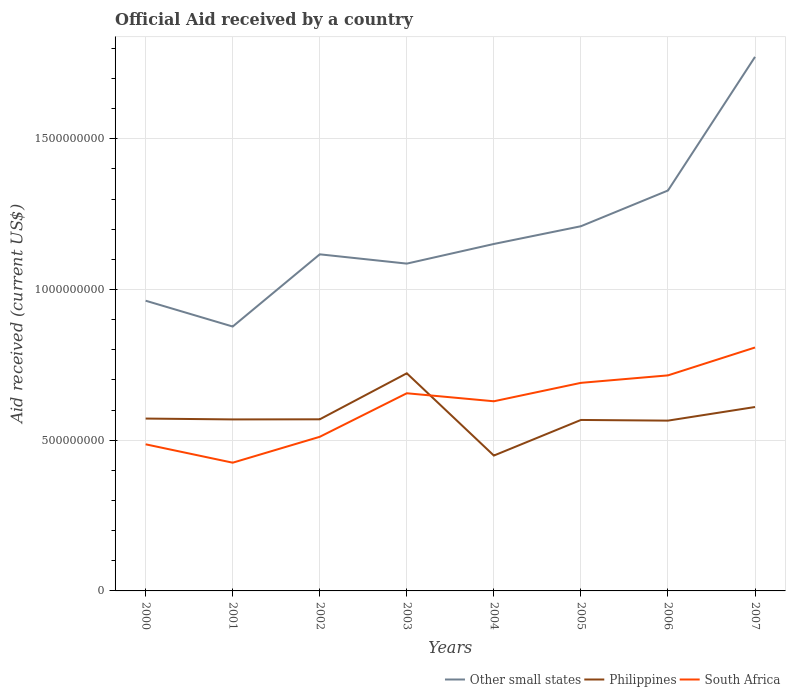Is the number of lines equal to the number of legend labels?
Ensure brevity in your answer.  Yes. Across all years, what is the maximum net official aid received in Philippines?
Offer a very short reply. 4.49e+08. What is the total net official aid received in Philippines in the graph?
Offer a very short reply. 4.33e+06. What is the difference between the highest and the second highest net official aid received in South Africa?
Provide a short and direct response. 3.82e+08. What is the difference between the highest and the lowest net official aid received in Philippines?
Keep it short and to the point. 2. What is the difference between two consecutive major ticks on the Y-axis?
Ensure brevity in your answer.  5.00e+08. Does the graph contain any zero values?
Your response must be concise. No. Where does the legend appear in the graph?
Offer a very short reply. Bottom right. What is the title of the graph?
Offer a very short reply. Official Aid received by a country. Does "American Samoa" appear as one of the legend labels in the graph?
Offer a terse response. No. What is the label or title of the X-axis?
Your answer should be compact. Years. What is the label or title of the Y-axis?
Keep it short and to the point. Aid received (current US$). What is the Aid received (current US$) of Other small states in 2000?
Ensure brevity in your answer.  9.63e+08. What is the Aid received (current US$) of Philippines in 2000?
Your answer should be compact. 5.72e+08. What is the Aid received (current US$) of South Africa in 2000?
Keep it short and to the point. 4.86e+08. What is the Aid received (current US$) in Other small states in 2001?
Give a very brief answer. 8.77e+08. What is the Aid received (current US$) in Philippines in 2001?
Offer a terse response. 5.69e+08. What is the Aid received (current US$) of South Africa in 2001?
Provide a short and direct response. 4.25e+08. What is the Aid received (current US$) in Other small states in 2002?
Your answer should be very brief. 1.12e+09. What is the Aid received (current US$) in Philippines in 2002?
Give a very brief answer. 5.69e+08. What is the Aid received (current US$) of South Africa in 2002?
Offer a very short reply. 5.11e+08. What is the Aid received (current US$) of Other small states in 2003?
Give a very brief answer. 1.09e+09. What is the Aid received (current US$) in Philippines in 2003?
Provide a succinct answer. 7.22e+08. What is the Aid received (current US$) of South Africa in 2003?
Offer a terse response. 6.56e+08. What is the Aid received (current US$) in Other small states in 2004?
Your response must be concise. 1.15e+09. What is the Aid received (current US$) of Philippines in 2004?
Give a very brief answer. 4.49e+08. What is the Aid received (current US$) of South Africa in 2004?
Provide a short and direct response. 6.29e+08. What is the Aid received (current US$) of Other small states in 2005?
Make the answer very short. 1.21e+09. What is the Aid received (current US$) in Philippines in 2005?
Your answer should be very brief. 5.67e+08. What is the Aid received (current US$) in South Africa in 2005?
Give a very brief answer. 6.90e+08. What is the Aid received (current US$) of Other small states in 2006?
Your response must be concise. 1.33e+09. What is the Aid received (current US$) of Philippines in 2006?
Ensure brevity in your answer.  5.65e+08. What is the Aid received (current US$) in South Africa in 2006?
Provide a short and direct response. 7.15e+08. What is the Aid received (current US$) of Other small states in 2007?
Your answer should be very brief. 1.77e+09. What is the Aid received (current US$) of Philippines in 2007?
Make the answer very short. 6.10e+08. What is the Aid received (current US$) in South Africa in 2007?
Give a very brief answer. 8.07e+08. Across all years, what is the maximum Aid received (current US$) in Other small states?
Your response must be concise. 1.77e+09. Across all years, what is the maximum Aid received (current US$) of Philippines?
Your response must be concise. 7.22e+08. Across all years, what is the maximum Aid received (current US$) of South Africa?
Provide a succinct answer. 8.07e+08. Across all years, what is the minimum Aid received (current US$) in Other small states?
Ensure brevity in your answer.  8.77e+08. Across all years, what is the minimum Aid received (current US$) in Philippines?
Provide a short and direct response. 4.49e+08. Across all years, what is the minimum Aid received (current US$) of South Africa?
Give a very brief answer. 4.25e+08. What is the total Aid received (current US$) in Other small states in the graph?
Make the answer very short. 9.50e+09. What is the total Aid received (current US$) of Philippines in the graph?
Provide a short and direct response. 4.62e+09. What is the total Aid received (current US$) in South Africa in the graph?
Your answer should be compact. 4.92e+09. What is the difference between the Aid received (current US$) of Other small states in 2000 and that in 2001?
Give a very brief answer. 8.57e+07. What is the difference between the Aid received (current US$) of Philippines in 2000 and that in 2001?
Give a very brief answer. 2.81e+06. What is the difference between the Aid received (current US$) in South Africa in 2000 and that in 2001?
Provide a succinct answer. 6.10e+07. What is the difference between the Aid received (current US$) of Other small states in 2000 and that in 2002?
Ensure brevity in your answer.  -1.54e+08. What is the difference between the Aid received (current US$) in Philippines in 2000 and that in 2002?
Provide a short and direct response. 2.48e+06. What is the difference between the Aid received (current US$) in South Africa in 2000 and that in 2002?
Make the answer very short. -2.49e+07. What is the difference between the Aid received (current US$) of Other small states in 2000 and that in 2003?
Offer a very short reply. -1.23e+08. What is the difference between the Aid received (current US$) in Philippines in 2000 and that in 2003?
Offer a terse response. -1.50e+08. What is the difference between the Aid received (current US$) of South Africa in 2000 and that in 2003?
Ensure brevity in your answer.  -1.69e+08. What is the difference between the Aid received (current US$) in Other small states in 2000 and that in 2004?
Provide a short and direct response. -1.88e+08. What is the difference between the Aid received (current US$) in Philippines in 2000 and that in 2004?
Give a very brief answer. 1.23e+08. What is the difference between the Aid received (current US$) of South Africa in 2000 and that in 2004?
Your answer should be compact. -1.43e+08. What is the difference between the Aid received (current US$) of Other small states in 2000 and that in 2005?
Offer a very short reply. -2.47e+08. What is the difference between the Aid received (current US$) of Philippines in 2000 and that in 2005?
Keep it short and to the point. 4.60e+06. What is the difference between the Aid received (current US$) of South Africa in 2000 and that in 2005?
Ensure brevity in your answer.  -2.04e+08. What is the difference between the Aid received (current US$) in Other small states in 2000 and that in 2006?
Your answer should be compact. -3.66e+08. What is the difference between the Aid received (current US$) of Philippines in 2000 and that in 2006?
Ensure brevity in your answer.  6.81e+06. What is the difference between the Aid received (current US$) of South Africa in 2000 and that in 2006?
Provide a succinct answer. -2.29e+08. What is the difference between the Aid received (current US$) of Other small states in 2000 and that in 2007?
Keep it short and to the point. -8.09e+08. What is the difference between the Aid received (current US$) in Philippines in 2000 and that in 2007?
Your answer should be compact. -3.83e+07. What is the difference between the Aid received (current US$) in South Africa in 2000 and that in 2007?
Your response must be concise. -3.21e+08. What is the difference between the Aid received (current US$) in Other small states in 2001 and that in 2002?
Your answer should be very brief. -2.40e+08. What is the difference between the Aid received (current US$) in Philippines in 2001 and that in 2002?
Offer a very short reply. -3.30e+05. What is the difference between the Aid received (current US$) in South Africa in 2001 and that in 2002?
Ensure brevity in your answer.  -8.59e+07. What is the difference between the Aid received (current US$) of Other small states in 2001 and that in 2003?
Provide a succinct answer. -2.09e+08. What is the difference between the Aid received (current US$) of Philippines in 2001 and that in 2003?
Make the answer very short. -1.53e+08. What is the difference between the Aid received (current US$) in South Africa in 2001 and that in 2003?
Offer a very short reply. -2.30e+08. What is the difference between the Aid received (current US$) in Other small states in 2001 and that in 2004?
Provide a succinct answer. -2.74e+08. What is the difference between the Aid received (current US$) of Philippines in 2001 and that in 2004?
Ensure brevity in your answer.  1.20e+08. What is the difference between the Aid received (current US$) of South Africa in 2001 and that in 2004?
Your answer should be compact. -2.04e+08. What is the difference between the Aid received (current US$) of Other small states in 2001 and that in 2005?
Offer a very short reply. -3.33e+08. What is the difference between the Aid received (current US$) of Philippines in 2001 and that in 2005?
Your answer should be compact. 1.79e+06. What is the difference between the Aid received (current US$) of South Africa in 2001 and that in 2005?
Offer a very short reply. -2.65e+08. What is the difference between the Aid received (current US$) in Other small states in 2001 and that in 2006?
Give a very brief answer. -4.51e+08. What is the difference between the Aid received (current US$) of Philippines in 2001 and that in 2006?
Ensure brevity in your answer.  4.00e+06. What is the difference between the Aid received (current US$) of South Africa in 2001 and that in 2006?
Your answer should be compact. -2.90e+08. What is the difference between the Aid received (current US$) of Other small states in 2001 and that in 2007?
Your answer should be very brief. -8.95e+08. What is the difference between the Aid received (current US$) in Philippines in 2001 and that in 2007?
Your response must be concise. -4.12e+07. What is the difference between the Aid received (current US$) in South Africa in 2001 and that in 2007?
Provide a short and direct response. -3.82e+08. What is the difference between the Aid received (current US$) in Other small states in 2002 and that in 2003?
Make the answer very short. 3.08e+07. What is the difference between the Aid received (current US$) in Philippines in 2002 and that in 2003?
Make the answer very short. -1.53e+08. What is the difference between the Aid received (current US$) of South Africa in 2002 and that in 2003?
Offer a very short reply. -1.44e+08. What is the difference between the Aid received (current US$) in Other small states in 2002 and that in 2004?
Your answer should be compact. -3.43e+07. What is the difference between the Aid received (current US$) in Philippines in 2002 and that in 2004?
Offer a terse response. 1.20e+08. What is the difference between the Aid received (current US$) of South Africa in 2002 and that in 2004?
Provide a short and direct response. -1.18e+08. What is the difference between the Aid received (current US$) of Other small states in 2002 and that in 2005?
Provide a succinct answer. -9.32e+07. What is the difference between the Aid received (current US$) of Philippines in 2002 and that in 2005?
Ensure brevity in your answer.  2.12e+06. What is the difference between the Aid received (current US$) in South Africa in 2002 and that in 2005?
Ensure brevity in your answer.  -1.79e+08. What is the difference between the Aid received (current US$) of Other small states in 2002 and that in 2006?
Offer a terse response. -2.12e+08. What is the difference between the Aid received (current US$) of Philippines in 2002 and that in 2006?
Give a very brief answer. 4.33e+06. What is the difference between the Aid received (current US$) of South Africa in 2002 and that in 2006?
Provide a succinct answer. -2.04e+08. What is the difference between the Aid received (current US$) in Other small states in 2002 and that in 2007?
Give a very brief answer. -6.55e+08. What is the difference between the Aid received (current US$) in Philippines in 2002 and that in 2007?
Keep it short and to the point. -4.08e+07. What is the difference between the Aid received (current US$) in South Africa in 2002 and that in 2007?
Your answer should be very brief. -2.96e+08. What is the difference between the Aid received (current US$) in Other small states in 2003 and that in 2004?
Your answer should be very brief. -6.51e+07. What is the difference between the Aid received (current US$) in Philippines in 2003 and that in 2004?
Make the answer very short. 2.73e+08. What is the difference between the Aid received (current US$) of South Africa in 2003 and that in 2004?
Offer a very short reply. 2.66e+07. What is the difference between the Aid received (current US$) in Other small states in 2003 and that in 2005?
Give a very brief answer. -1.24e+08. What is the difference between the Aid received (current US$) in Philippines in 2003 and that in 2005?
Your answer should be compact. 1.55e+08. What is the difference between the Aid received (current US$) of South Africa in 2003 and that in 2005?
Provide a succinct answer. -3.45e+07. What is the difference between the Aid received (current US$) in Other small states in 2003 and that in 2006?
Provide a succinct answer. -2.43e+08. What is the difference between the Aid received (current US$) in Philippines in 2003 and that in 2006?
Make the answer very short. 1.57e+08. What is the difference between the Aid received (current US$) of South Africa in 2003 and that in 2006?
Give a very brief answer. -5.93e+07. What is the difference between the Aid received (current US$) of Other small states in 2003 and that in 2007?
Provide a short and direct response. -6.86e+08. What is the difference between the Aid received (current US$) of Philippines in 2003 and that in 2007?
Your response must be concise. 1.12e+08. What is the difference between the Aid received (current US$) in South Africa in 2003 and that in 2007?
Keep it short and to the point. -1.52e+08. What is the difference between the Aid received (current US$) in Other small states in 2004 and that in 2005?
Keep it short and to the point. -5.88e+07. What is the difference between the Aid received (current US$) in Philippines in 2004 and that in 2005?
Your response must be concise. -1.18e+08. What is the difference between the Aid received (current US$) of South Africa in 2004 and that in 2005?
Offer a terse response. -6.11e+07. What is the difference between the Aid received (current US$) in Other small states in 2004 and that in 2006?
Offer a very short reply. -1.77e+08. What is the difference between the Aid received (current US$) in Philippines in 2004 and that in 2006?
Provide a succinct answer. -1.16e+08. What is the difference between the Aid received (current US$) of South Africa in 2004 and that in 2006?
Provide a short and direct response. -8.59e+07. What is the difference between the Aid received (current US$) in Other small states in 2004 and that in 2007?
Offer a very short reply. -6.21e+08. What is the difference between the Aid received (current US$) in Philippines in 2004 and that in 2007?
Your response must be concise. -1.61e+08. What is the difference between the Aid received (current US$) of South Africa in 2004 and that in 2007?
Your answer should be compact. -1.78e+08. What is the difference between the Aid received (current US$) in Other small states in 2005 and that in 2006?
Give a very brief answer. -1.19e+08. What is the difference between the Aid received (current US$) in Philippines in 2005 and that in 2006?
Keep it short and to the point. 2.21e+06. What is the difference between the Aid received (current US$) in South Africa in 2005 and that in 2006?
Provide a succinct answer. -2.48e+07. What is the difference between the Aid received (current US$) in Other small states in 2005 and that in 2007?
Ensure brevity in your answer.  -5.62e+08. What is the difference between the Aid received (current US$) in Philippines in 2005 and that in 2007?
Keep it short and to the point. -4.29e+07. What is the difference between the Aid received (current US$) of South Africa in 2005 and that in 2007?
Give a very brief answer. -1.17e+08. What is the difference between the Aid received (current US$) of Other small states in 2006 and that in 2007?
Provide a short and direct response. -4.43e+08. What is the difference between the Aid received (current US$) in Philippines in 2006 and that in 2007?
Keep it short and to the point. -4.52e+07. What is the difference between the Aid received (current US$) in South Africa in 2006 and that in 2007?
Provide a succinct answer. -9.25e+07. What is the difference between the Aid received (current US$) of Other small states in 2000 and the Aid received (current US$) of Philippines in 2001?
Keep it short and to the point. 3.94e+08. What is the difference between the Aid received (current US$) of Other small states in 2000 and the Aid received (current US$) of South Africa in 2001?
Offer a very short reply. 5.37e+08. What is the difference between the Aid received (current US$) of Philippines in 2000 and the Aid received (current US$) of South Africa in 2001?
Provide a short and direct response. 1.46e+08. What is the difference between the Aid received (current US$) in Other small states in 2000 and the Aid received (current US$) in Philippines in 2002?
Give a very brief answer. 3.93e+08. What is the difference between the Aid received (current US$) of Other small states in 2000 and the Aid received (current US$) of South Africa in 2002?
Your answer should be very brief. 4.51e+08. What is the difference between the Aid received (current US$) in Philippines in 2000 and the Aid received (current US$) in South Africa in 2002?
Your answer should be very brief. 6.05e+07. What is the difference between the Aid received (current US$) of Other small states in 2000 and the Aid received (current US$) of Philippines in 2003?
Keep it short and to the point. 2.41e+08. What is the difference between the Aid received (current US$) in Other small states in 2000 and the Aid received (current US$) in South Africa in 2003?
Your answer should be very brief. 3.07e+08. What is the difference between the Aid received (current US$) of Philippines in 2000 and the Aid received (current US$) of South Africa in 2003?
Your answer should be very brief. -8.40e+07. What is the difference between the Aid received (current US$) of Other small states in 2000 and the Aid received (current US$) of Philippines in 2004?
Your answer should be very brief. 5.14e+08. What is the difference between the Aid received (current US$) in Other small states in 2000 and the Aid received (current US$) in South Africa in 2004?
Give a very brief answer. 3.34e+08. What is the difference between the Aid received (current US$) in Philippines in 2000 and the Aid received (current US$) in South Africa in 2004?
Offer a terse response. -5.74e+07. What is the difference between the Aid received (current US$) in Other small states in 2000 and the Aid received (current US$) in Philippines in 2005?
Keep it short and to the point. 3.96e+08. What is the difference between the Aid received (current US$) in Other small states in 2000 and the Aid received (current US$) in South Africa in 2005?
Make the answer very short. 2.72e+08. What is the difference between the Aid received (current US$) in Philippines in 2000 and the Aid received (current US$) in South Africa in 2005?
Make the answer very short. -1.18e+08. What is the difference between the Aid received (current US$) of Other small states in 2000 and the Aid received (current US$) of Philippines in 2006?
Provide a succinct answer. 3.98e+08. What is the difference between the Aid received (current US$) in Other small states in 2000 and the Aid received (current US$) in South Africa in 2006?
Ensure brevity in your answer.  2.48e+08. What is the difference between the Aid received (current US$) of Philippines in 2000 and the Aid received (current US$) of South Africa in 2006?
Keep it short and to the point. -1.43e+08. What is the difference between the Aid received (current US$) of Other small states in 2000 and the Aid received (current US$) of Philippines in 2007?
Your response must be concise. 3.53e+08. What is the difference between the Aid received (current US$) in Other small states in 2000 and the Aid received (current US$) in South Africa in 2007?
Offer a very short reply. 1.55e+08. What is the difference between the Aid received (current US$) of Philippines in 2000 and the Aid received (current US$) of South Africa in 2007?
Your answer should be compact. -2.36e+08. What is the difference between the Aid received (current US$) of Other small states in 2001 and the Aid received (current US$) of Philippines in 2002?
Give a very brief answer. 3.08e+08. What is the difference between the Aid received (current US$) of Other small states in 2001 and the Aid received (current US$) of South Africa in 2002?
Offer a very short reply. 3.66e+08. What is the difference between the Aid received (current US$) of Philippines in 2001 and the Aid received (current US$) of South Africa in 2002?
Ensure brevity in your answer.  5.77e+07. What is the difference between the Aid received (current US$) of Other small states in 2001 and the Aid received (current US$) of Philippines in 2003?
Provide a succinct answer. 1.55e+08. What is the difference between the Aid received (current US$) in Other small states in 2001 and the Aid received (current US$) in South Africa in 2003?
Keep it short and to the point. 2.21e+08. What is the difference between the Aid received (current US$) in Philippines in 2001 and the Aid received (current US$) in South Africa in 2003?
Keep it short and to the point. -8.68e+07. What is the difference between the Aid received (current US$) of Other small states in 2001 and the Aid received (current US$) of Philippines in 2004?
Provide a succinct answer. 4.28e+08. What is the difference between the Aid received (current US$) of Other small states in 2001 and the Aid received (current US$) of South Africa in 2004?
Keep it short and to the point. 2.48e+08. What is the difference between the Aid received (current US$) of Philippines in 2001 and the Aid received (current US$) of South Africa in 2004?
Your answer should be very brief. -6.02e+07. What is the difference between the Aid received (current US$) of Other small states in 2001 and the Aid received (current US$) of Philippines in 2005?
Provide a short and direct response. 3.10e+08. What is the difference between the Aid received (current US$) in Other small states in 2001 and the Aid received (current US$) in South Africa in 2005?
Give a very brief answer. 1.87e+08. What is the difference between the Aid received (current US$) of Philippines in 2001 and the Aid received (current US$) of South Africa in 2005?
Give a very brief answer. -1.21e+08. What is the difference between the Aid received (current US$) in Other small states in 2001 and the Aid received (current US$) in Philippines in 2006?
Offer a terse response. 3.12e+08. What is the difference between the Aid received (current US$) in Other small states in 2001 and the Aid received (current US$) in South Africa in 2006?
Your answer should be compact. 1.62e+08. What is the difference between the Aid received (current US$) in Philippines in 2001 and the Aid received (current US$) in South Africa in 2006?
Your answer should be compact. -1.46e+08. What is the difference between the Aid received (current US$) of Other small states in 2001 and the Aid received (current US$) of Philippines in 2007?
Give a very brief answer. 2.67e+08. What is the difference between the Aid received (current US$) of Other small states in 2001 and the Aid received (current US$) of South Africa in 2007?
Provide a short and direct response. 6.95e+07. What is the difference between the Aid received (current US$) of Philippines in 2001 and the Aid received (current US$) of South Africa in 2007?
Give a very brief answer. -2.39e+08. What is the difference between the Aid received (current US$) of Other small states in 2002 and the Aid received (current US$) of Philippines in 2003?
Keep it short and to the point. 3.95e+08. What is the difference between the Aid received (current US$) in Other small states in 2002 and the Aid received (current US$) in South Africa in 2003?
Your answer should be compact. 4.61e+08. What is the difference between the Aid received (current US$) of Philippines in 2002 and the Aid received (current US$) of South Africa in 2003?
Your response must be concise. -8.64e+07. What is the difference between the Aid received (current US$) in Other small states in 2002 and the Aid received (current US$) in Philippines in 2004?
Your answer should be very brief. 6.68e+08. What is the difference between the Aid received (current US$) in Other small states in 2002 and the Aid received (current US$) in South Africa in 2004?
Provide a short and direct response. 4.87e+08. What is the difference between the Aid received (current US$) of Philippines in 2002 and the Aid received (current US$) of South Africa in 2004?
Give a very brief answer. -5.98e+07. What is the difference between the Aid received (current US$) in Other small states in 2002 and the Aid received (current US$) in Philippines in 2005?
Offer a very short reply. 5.49e+08. What is the difference between the Aid received (current US$) in Other small states in 2002 and the Aid received (current US$) in South Africa in 2005?
Your answer should be compact. 4.26e+08. What is the difference between the Aid received (current US$) in Philippines in 2002 and the Aid received (current US$) in South Africa in 2005?
Your answer should be compact. -1.21e+08. What is the difference between the Aid received (current US$) of Other small states in 2002 and the Aid received (current US$) of Philippines in 2006?
Your answer should be compact. 5.52e+08. What is the difference between the Aid received (current US$) of Other small states in 2002 and the Aid received (current US$) of South Africa in 2006?
Provide a short and direct response. 4.02e+08. What is the difference between the Aid received (current US$) in Philippines in 2002 and the Aid received (current US$) in South Africa in 2006?
Give a very brief answer. -1.46e+08. What is the difference between the Aid received (current US$) of Other small states in 2002 and the Aid received (current US$) of Philippines in 2007?
Your answer should be very brief. 5.07e+08. What is the difference between the Aid received (current US$) of Other small states in 2002 and the Aid received (current US$) of South Africa in 2007?
Ensure brevity in your answer.  3.09e+08. What is the difference between the Aid received (current US$) of Philippines in 2002 and the Aid received (current US$) of South Africa in 2007?
Your answer should be compact. -2.38e+08. What is the difference between the Aid received (current US$) of Other small states in 2003 and the Aid received (current US$) of Philippines in 2004?
Keep it short and to the point. 6.37e+08. What is the difference between the Aid received (current US$) in Other small states in 2003 and the Aid received (current US$) in South Africa in 2004?
Offer a terse response. 4.57e+08. What is the difference between the Aid received (current US$) in Philippines in 2003 and the Aid received (current US$) in South Africa in 2004?
Ensure brevity in your answer.  9.28e+07. What is the difference between the Aid received (current US$) of Other small states in 2003 and the Aid received (current US$) of Philippines in 2005?
Keep it short and to the point. 5.19e+08. What is the difference between the Aid received (current US$) in Other small states in 2003 and the Aid received (current US$) in South Africa in 2005?
Your response must be concise. 3.96e+08. What is the difference between the Aid received (current US$) in Philippines in 2003 and the Aid received (current US$) in South Africa in 2005?
Provide a succinct answer. 3.17e+07. What is the difference between the Aid received (current US$) in Other small states in 2003 and the Aid received (current US$) in Philippines in 2006?
Your answer should be very brief. 5.21e+08. What is the difference between the Aid received (current US$) of Other small states in 2003 and the Aid received (current US$) of South Africa in 2006?
Provide a succinct answer. 3.71e+08. What is the difference between the Aid received (current US$) in Philippines in 2003 and the Aid received (current US$) in South Africa in 2006?
Your answer should be compact. 6.95e+06. What is the difference between the Aid received (current US$) in Other small states in 2003 and the Aid received (current US$) in Philippines in 2007?
Make the answer very short. 4.76e+08. What is the difference between the Aid received (current US$) of Other small states in 2003 and the Aid received (current US$) of South Africa in 2007?
Your response must be concise. 2.78e+08. What is the difference between the Aid received (current US$) in Philippines in 2003 and the Aid received (current US$) in South Africa in 2007?
Give a very brief answer. -8.56e+07. What is the difference between the Aid received (current US$) in Other small states in 2004 and the Aid received (current US$) in Philippines in 2005?
Your answer should be very brief. 5.84e+08. What is the difference between the Aid received (current US$) of Other small states in 2004 and the Aid received (current US$) of South Africa in 2005?
Make the answer very short. 4.61e+08. What is the difference between the Aid received (current US$) of Philippines in 2004 and the Aid received (current US$) of South Africa in 2005?
Provide a succinct answer. -2.41e+08. What is the difference between the Aid received (current US$) in Other small states in 2004 and the Aid received (current US$) in Philippines in 2006?
Your answer should be compact. 5.86e+08. What is the difference between the Aid received (current US$) of Other small states in 2004 and the Aid received (current US$) of South Africa in 2006?
Offer a terse response. 4.36e+08. What is the difference between the Aid received (current US$) in Philippines in 2004 and the Aid received (current US$) in South Africa in 2006?
Your response must be concise. -2.66e+08. What is the difference between the Aid received (current US$) in Other small states in 2004 and the Aid received (current US$) in Philippines in 2007?
Give a very brief answer. 5.41e+08. What is the difference between the Aid received (current US$) of Other small states in 2004 and the Aid received (current US$) of South Africa in 2007?
Make the answer very short. 3.43e+08. What is the difference between the Aid received (current US$) of Philippines in 2004 and the Aid received (current US$) of South Africa in 2007?
Keep it short and to the point. -3.58e+08. What is the difference between the Aid received (current US$) in Other small states in 2005 and the Aid received (current US$) in Philippines in 2006?
Offer a terse response. 6.45e+08. What is the difference between the Aid received (current US$) in Other small states in 2005 and the Aid received (current US$) in South Africa in 2006?
Provide a succinct answer. 4.95e+08. What is the difference between the Aid received (current US$) in Philippines in 2005 and the Aid received (current US$) in South Africa in 2006?
Offer a terse response. -1.48e+08. What is the difference between the Aid received (current US$) in Other small states in 2005 and the Aid received (current US$) in Philippines in 2007?
Make the answer very short. 6.00e+08. What is the difference between the Aid received (current US$) of Other small states in 2005 and the Aid received (current US$) of South Africa in 2007?
Provide a succinct answer. 4.02e+08. What is the difference between the Aid received (current US$) in Philippines in 2005 and the Aid received (current US$) in South Africa in 2007?
Ensure brevity in your answer.  -2.40e+08. What is the difference between the Aid received (current US$) in Other small states in 2006 and the Aid received (current US$) in Philippines in 2007?
Your response must be concise. 7.18e+08. What is the difference between the Aid received (current US$) in Other small states in 2006 and the Aid received (current US$) in South Africa in 2007?
Make the answer very short. 5.21e+08. What is the difference between the Aid received (current US$) of Philippines in 2006 and the Aid received (current US$) of South Africa in 2007?
Ensure brevity in your answer.  -2.43e+08. What is the average Aid received (current US$) in Other small states per year?
Provide a succinct answer. 1.19e+09. What is the average Aid received (current US$) in Philippines per year?
Offer a terse response. 5.78e+08. What is the average Aid received (current US$) in South Africa per year?
Offer a very short reply. 6.15e+08. In the year 2000, what is the difference between the Aid received (current US$) in Other small states and Aid received (current US$) in Philippines?
Your response must be concise. 3.91e+08. In the year 2000, what is the difference between the Aid received (current US$) of Other small states and Aid received (current US$) of South Africa?
Offer a terse response. 4.76e+08. In the year 2000, what is the difference between the Aid received (current US$) of Philippines and Aid received (current US$) of South Africa?
Offer a very short reply. 8.54e+07. In the year 2001, what is the difference between the Aid received (current US$) in Other small states and Aid received (current US$) in Philippines?
Your answer should be compact. 3.08e+08. In the year 2001, what is the difference between the Aid received (current US$) in Other small states and Aid received (current US$) in South Africa?
Ensure brevity in your answer.  4.52e+08. In the year 2001, what is the difference between the Aid received (current US$) of Philippines and Aid received (current US$) of South Africa?
Ensure brevity in your answer.  1.44e+08. In the year 2002, what is the difference between the Aid received (current US$) of Other small states and Aid received (current US$) of Philippines?
Your answer should be very brief. 5.47e+08. In the year 2002, what is the difference between the Aid received (current US$) in Other small states and Aid received (current US$) in South Africa?
Your answer should be very brief. 6.05e+08. In the year 2002, what is the difference between the Aid received (current US$) in Philippines and Aid received (current US$) in South Africa?
Your answer should be compact. 5.80e+07. In the year 2003, what is the difference between the Aid received (current US$) in Other small states and Aid received (current US$) in Philippines?
Keep it short and to the point. 3.64e+08. In the year 2003, what is the difference between the Aid received (current US$) of Other small states and Aid received (current US$) of South Africa?
Provide a succinct answer. 4.30e+08. In the year 2003, what is the difference between the Aid received (current US$) of Philippines and Aid received (current US$) of South Africa?
Your response must be concise. 6.63e+07. In the year 2004, what is the difference between the Aid received (current US$) in Other small states and Aid received (current US$) in Philippines?
Provide a succinct answer. 7.02e+08. In the year 2004, what is the difference between the Aid received (current US$) in Other small states and Aid received (current US$) in South Africa?
Keep it short and to the point. 5.22e+08. In the year 2004, what is the difference between the Aid received (current US$) in Philippines and Aid received (current US$) in South Africa?
Provide a succinct answer. -1.80e+08. In the year 2005, what is the difference between the Aid received (current US$) of Other small states and Aid received (current US$) of Philippines?
Ensure brevity in your answer.  6.43e+08. In the year 2005, what is the difference between the Aid received (current US$) of Other small states and Aid received (current US$) of South Africa?
Provide a succinct answer. 5.20e+08. In the year 2005, what is the difference between the Aid received (current US$) in Philippines and Aid received (current US$) in South Africa?
Give a very brief answer. -1.23e+08. In the year 2006, what is the difference between the Aid received (current US$) in Other small states and Aid received (current US$) in Philippines?
Provide a succinct answer. 7.63e+08. In the year 2006, what is the difference between the Aid received (current US$) of Other small states and Aid received (current US$) of South Africa?
Give a very brief answer. 6.13e+08. In the year 2006, what is the difference between the Aid received (current US$) in Philippines and Aid received (current US$) in South Africa?
Make the answer very short. -1.50e+08. In the year 2007, what is the difference between the Aid received (current US$) of Other small states and Aid received (current US$) of Philippines?
Your answer should be very brief. 1.16e+09. In the year 2007, what is the difference between the Aid received (current US$) of Other small states and Aid received (current US$) of South Africa?
Provide a succinct answer. 9.64e+08. In the year 2007, what is the difference between the Aid received (current US$) of Philippines and Aid received (current US$) of South Africa?
Keep it short and to the point. -1.97e+08. What is the ratio of the Aid received (current US$) of Other small states in 2000 to that in 2001?
Provide a short and direct response. 1.1. What is the ratio of the Aid received (current US$) of South Africa in 2000 to that in 2001?
Provide a short and direct response. 1.14. What is the ratio of the Aid received (current US$) of Other small states in 2000 to that in 2002?
Offer a very short reply. 0.86. What is the ratio of the Aid received (current US$) in South Africa in 2000 to that in 2002?
Keep it short and to the point. 0.95. What is the ratio of the Aid received (current US$) in Other small states in 2000 to that in 2003?
Provide a short and direct response. 0.89. What is the ratio of the Aid received (current US$) of Philippines in 2000 to that in 2003?
Your response must be concise. 0.79. What is the ratio of the Aid received (current US$) of South Africa in 2000 to that in 2003?
Provide a succinct answer. 0.74. What is the ratio of the Aid received (current US$) of Other small states in 2000 to that in 2004?
Provide a short and direct response. 0.84. What is the ratio of the Aid received (current US$) in Philippines in 2000 to that in 2004?
Offer a very short reply. 1.27. What is the ratio of the Aid received (current US$) of South Africa in 2000 to that in 2004?
Provide a short and direct response. 0.77. What is the ratio of the Aid received (current US$) in Other small states in 2000 to that in 2005?
Offer a terse response. 0.8. What is the ratio of the Aid received (current US$) in Philippines in 2000 to that in 2005?
Offer a very short reply. 1.01. What is the ratio of the Aid received (current US$) in South Africa in 2000 to that in 2005?
Your answer should be compact. 0.7. What is the ratio of the Aid received (current US$) in Other small states in 2000 to that in 2006?
Provide a short and direct response. 0.72. What is the ratio of the Aid received (current US$) in Philippines in 2000 to that in 2006?
Give a very brief answer. 1.01. What is the ratio of the Aid received (current US$) of South Africa in 2000 to that in 2006?
Ensure brevity in your answer.  0.68. What is the ratio of the Aid received (current US$) in Other small states in 2000 to that in 2007?
Your answer should be compact. 0.54. What is the ratio of the Aid received (current US$) in Philippines in 2000 to that in 2007?
Your response must be concise. 0.94. What is the ratio of the Aid received (current US$) of South Africa in 2000 to that in 2007?
Provide a succinct answer. 0.6. What is the ratio of the Aid received (current US$) in Other small states in 2001 to that in 2002?
Your answer should be very brief. 0.79. What is the ratio of the Aid received (current US$) of Philippines in 2001 to that in 2002?
Make the answer very short. 1. What is the ratio of the Aid received (current US$) of South Africa in 2001 to that in 2002?
Provide a short and direct response. 0.83. What is the ratio of the Aid received (current US$) in Other small states in 2001 to that in 2003?
Make the answer very short. 0.81. What is the ratio of the Aid received (current US$) in Philippines in 2001 to that in 2003?
Ensure brevity in your answer.  0.79. What is the ratio of the Aid received (current US$) of South Africa in 2001 to that in 2003?
Your response must be concise. 0.65. What is the ratio of the Aid received (current US$) of Other small states in 2001 to that in 2004?
Give a very brief answer. 0.76. What is the ratio of the Aid received (current US$) in Philippines in 2001 to that in 2004?
Your answer should be compact. 1.27. What is the ratio of the Aid received (current US$) of South Africa in 2001 to that in 2004?
Provide a succinct answer. 0.68. What is the ratio of the Aid received (current US$) in Other small states in 2001 to that in 2005?
Provide a succinct answer. 0.72. What is the ratio of the Aid received (current US$) of Philippines in 2001 to that in 2005?
Give a very brief answer. 1. What is the ratio of the Aid received (current US$) of South Africa in 2001 to that in 2005?
Offer a very short reply. 0.62. What is the ratio of the Aid received (current US$) in Other small states in 2001 to that in 2006?
Your answer should be compact. 0.66. What is the ratio of the Aid received (current US$) in Philippines in 2001 to that in 2006?
Ensure brevity in your answer.  1.01. What is the ratio of the Aid received (current US$) of South Africa in 2001 to that in 2006?
Ensure brevity in your answer.  0.59. What is the ratio of the Aid received (current US$) in Other small states in 2001 to that in 2007?
Keep it short and to the point. 0.49. What is the ratio of the Aid received (current US$) in Philippines in 2001 to that in 2007?
Your answer should be compact. 0.93. What is the ratio of the Aid received (current US$) in South Africa in 2001 to that in 2007?
Give a very brief answer. 0.53. What is the ratio of the Aid received (current US$) in Other small states in 2002 to that in 2003?
Offer a terse response. 1.03. What is the ratio of the Aid received (current US$) in Philippines in 2002 to that in 2003?
Offer a terse response. 0.79. What is the ratio of the Aid received (current US$) in South Africa in 2002 to that in 2003?
Provide a short and direct response. 0.78. What is the ratio of the Aid received (current US$) in Other small states in 2002 to that in 2004?
Offer a very short reply. 0.97. What is the ratio of the Aid received (current US$) in Philippines in 2002 to that in 2004?
Offer a very short reply. 1.27. What is the ratio of the Aid received (current US$) in South Africa in 2002 to that in 2004?
Make the answer very short. 0.81. What is the ratio of the Aid received (current US$) in Other small states in 2002 to that in 2005?
Provide a short and direct response. 0.92. What is the ratio of the Aid received (current US$) of Philippines in 2002 to that in 2005?
Offer a very short reply. 1. What is the ratio of the Aid received (current US$) of South Africa in 2002 to that in 2005?
Your answer should be very brief. 0.74. What is the ratio of the Aid received (current US$) of Other small states in 2002 to that in 2006?
Provide a short and direct response. 0.84. What is the ratio of the Aid received (current US$) of Philippines in 2002 to that in 2006?
Offer a very short reply. 1.01. What is the ratio of the Aid received (current US$) in South Africa in 2002 to that in 2006?
Provide a short and direct response. 0.71. What is the ratio of the Aid received (current US$) in Other small states in 2002 to that in 2007?
Offer a terse response. 0.63. What is the ratio of the Aid received (current US$) in Philippines in 2002 to that in 2007?
Provide a succinct answer. 0.93. What is the ratio of the Aid received (current US$) of South Africa in 2002 to that in 2007?
Keep it short and to the point. 0.63. What is the ratio of the Aid received (current US$) in Other small states in 2003 to that in 2004?
Your answer should be very brief. 0.94. What is the ratio of the Aid received (current US$) in Philippines in 2003 to that in 2004?
Your answer should be compact. 1.61. What is the ratio of the Aid received (current US$) of South Africa in 2003 to that in 2004?
Offer a terse response. 1.04. What is the ratio of the Aid received (current US$) of Other small states in 2003 to that in 2005?
Provide a short and direct response. 0.9. What is the ratio of the Aid received (current US$) in Philippines in 2003 to that in 2005?
Provide a succinct answer. 1.27. What is the ratio of the Aid received (current US$) in South Africa in 2003 to that in 2005?
Provide a short and direct response. 0.95. What is the ratio of the Aid received (current US$) of Other small states in 2003 to that in 2006?
Provide a succinct answer. 0.82. What is the ratio of the Aid received (current US$) in Philippines in 2003 to that in 2006?
Make the answer very short. 1.28. What is the ratio of the Aid received (current US$) of South Africa in 2003 to that in 2006?
Keep it short and to the point. 0.92. What is the ratio of the Aid received (current US$) in Other small states in 2003 to that in 2007?
Offer a terse response. 0.61. What is the ratio of the Aid received (current US$) of Philippines in 2003 to that in 2007?
Keep it short and to the point. 1.18. What is the ratio of the Aid received (current US$) of South Africa in 2003 to that in 2007?
Ensure brevity in your answer.  0.81. What is the ratio of the Aid received (current US$) of Other small states in 2004 to that in 2005?
Provide a short and direct response. 0.95. What is the ratio of the Aid received (current US$) of Philippines in 2004 to that in 2005?
Give a very brief answer. 0.79. What is the ratio of the Aid received (current US$) in South Africa in 2004 to that in 2005?
Ensure brevity in your answer.  0.91. What is the ratio of the Aid received (current US$) in Other small states in 2004 to that in 2006?
Provide a short and direct response. 0.87. What is the ratio of the Aid received (current US$) of Philippines in 2004 to that in 2006?
Provide a short and direct response. 0.79. What is the ratio of the Aid received (current US$) of South Africa in 2004 to that in 2006?
Provide a short and direct response. 0.88. What is the ratio of the Aid received (current US$) of Other small states in 2004 to that in 2007?
Offer a terse response. 0.65. What is the ratio of the Aid received (current US$) of Philippines in 2004 to that in 2007?
Provide a short and direct response. 0.74. What is the ratio of the Aid received (current US$) of South Africa in 2004 to that in 2007?
Offer a terse response. 0.78. What is the ratio of the Aid received (current US$) in Other small states in 2005 to that in 2006?
Keep it short and to the point. 0.91. What is the ratio of the Aid received (current US$) in Philippines in 2005 to that in 2006?
Offer a terse response. 1. What is the ratio of the Aid received (current US$) of South Africa in 2005 to that in 2006?
Ensure brevity in your answer.  0.97. What is the ratio of the Aid received (current US$) of Other small states in 2005 to that in 2007?
Provide a short and direct response. 0.68. What is the ratio of the Aid received (current US$) in Philippines in 2005 to that in 2007?
Your response must be concise. 0.93. What is the ratio of the Aid received (current US$) of South Africa in 2005 to that in 2007?
Offer a terse response. 0.85. What is the ratio of the Aid received (current US$) of Other small states in 2006 to that in 2007?
Offer a very short reply. 0.75. What is the ratio of the Aid received (current US$) in Philippines in 2006 to that in 2007?
Keep it short and to the point. 0.93. What is the ratio of the Aid received (current US$) of South Africa in 2006 to that in 2007?
Your answer should be very brief. 0.89. What is the difference between the highest and the second highest Aid received (current US$) in Other small states?
Offer a very short reply. 4.43e+08. What is the difference between the highest and the second highest Aid received (current US$) in Philippines?
Provide a short and direct response. 1.12e+08. What is the difference between the highest and the second highest Aid received (current US$) in South Africa?
Your answer should be compact. 9.25e+07. What is the difference between the highest and the lowest Aid received (current US$) in Other small states?
Your answer should be compact. 8.95e+08. What is the difference between the highest and the lowest Aid received (current US$) in Philippines?
Your answer should be very brief. 2.73e+08. What is the difference between the highest and the lowest Aid received (current US$) of South Africa?
Offer a very short reply. 3.82e+08. 